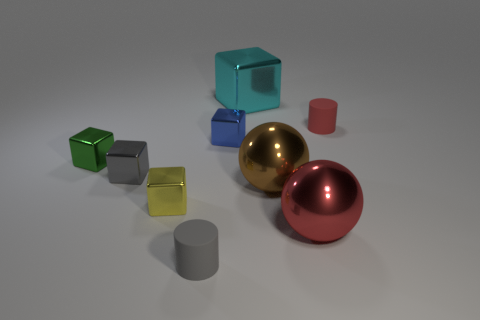Are there more small red rubber objects that are to the left of the yellow cube than big red shiny balls left of the big cyan metal cube?
Your answer should be very brief. No. Are the tiny blue block and the brown object in front of the tiny red matte cylinder made of the same material?
Your answer should be compact. Yes. Is there anything else that has the same shape as the tiny yellow object?
Provide a succinct answer. Yes. What color is the small metal block that is right of the small gray block and in front of the tiny green thing?
Provide a succinct answer. Yellow. What shape is the rubber thing that is on the right side of the cyan block?
Offer a terse response. Cylinder. What is the size of the cylinder behind the tiny gray thing that is behind the gray object in front of the brown metal object?
Your answer should be very brief. Small. How many cyan blocks are in front of the matte thing in front of the tiny blue object?
Offer a very short reply. 0. There is a metal object that is behind the yellow metal object and in front of the small gray metallic cube; how big is it?
Keep it short and to the point. Large. How many rubber objects are large objects or large red balls?
Offer a terse response. 0. What is the material of the big cyan thing?
Make the answer very short. Metal. 